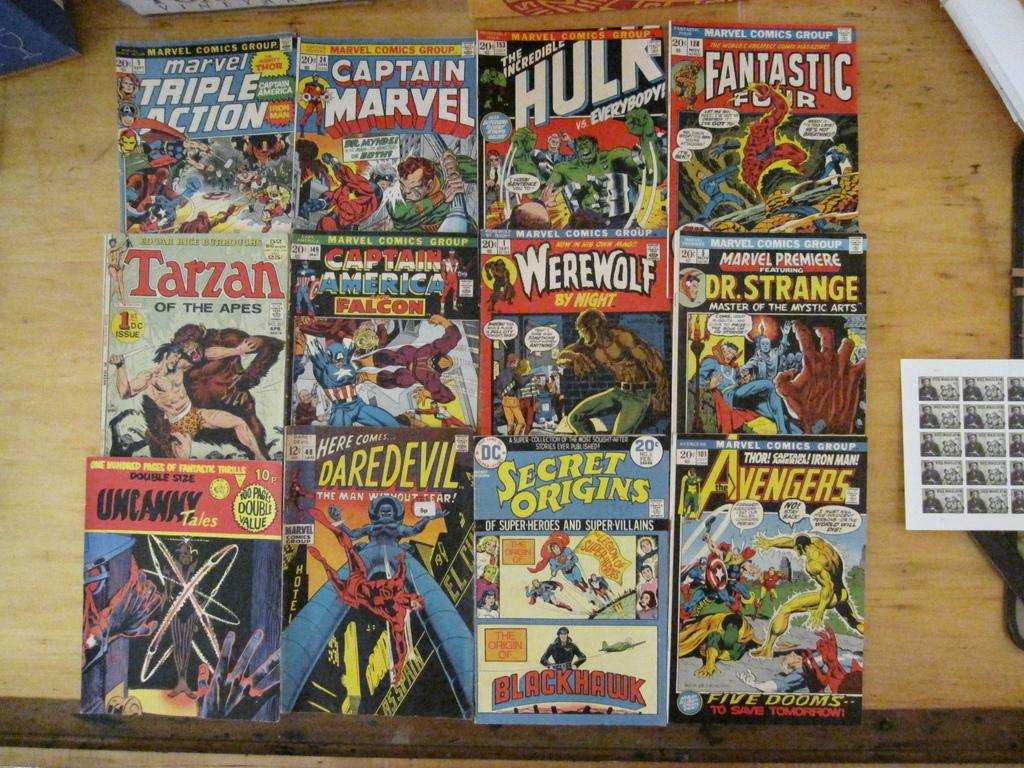Provide a one-sentence caption for the provided image. Many comic books including The Incredible Hulk are laid out on a wooden surface. 